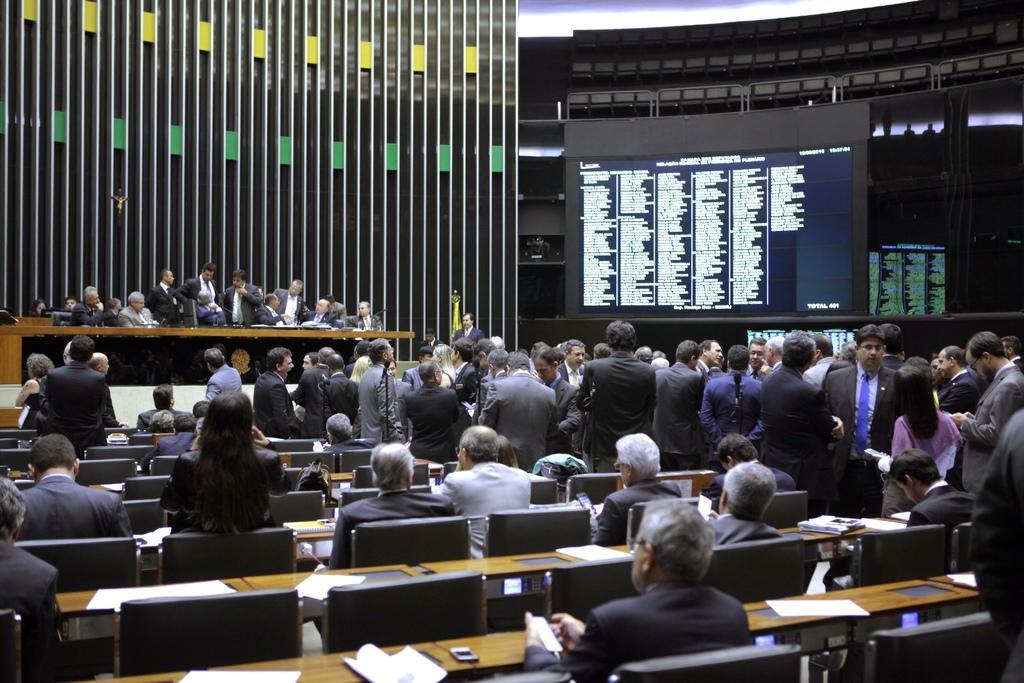How would you summarize this image in a sentence or two? in this image there are many people seated on the left side. on the right side people are standing. at the back people are talking to each other. on the right back there is a screen displayed. 